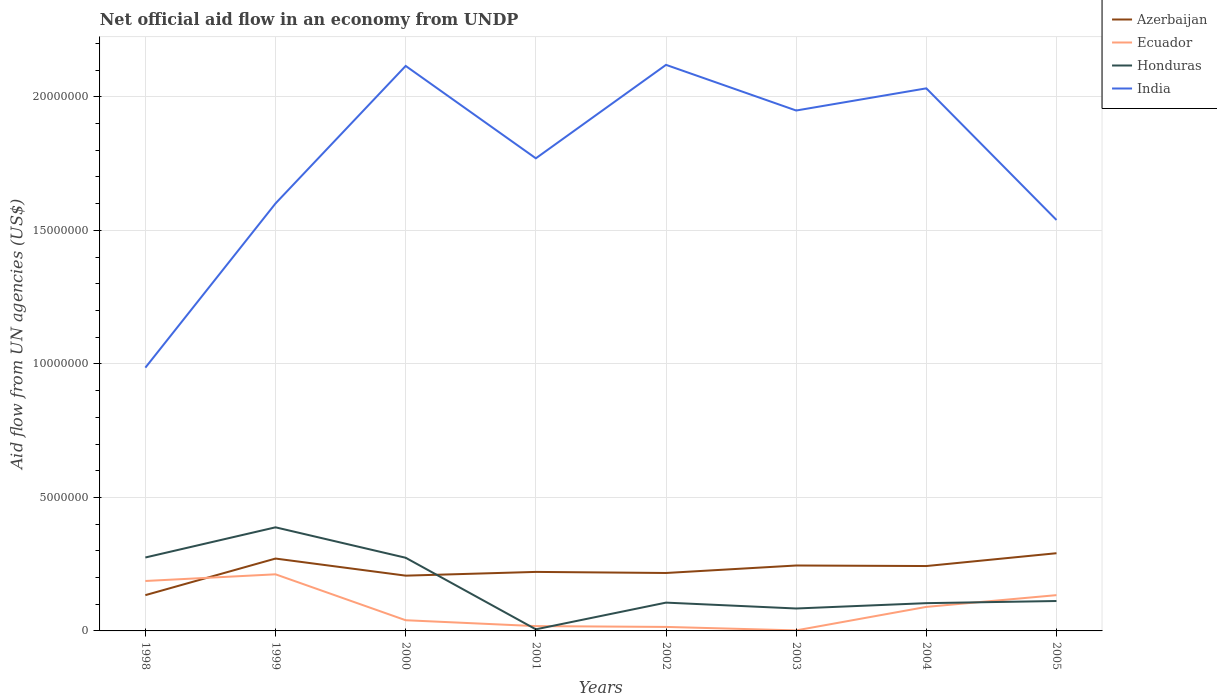Is the number of lines equal to the number of legend labels?
Offer a very short reply. Yes. Across all years, what is the maximum net official aid flow in Honduras?
Offer a very short reply. 6.00e+04. What is the total net official aid flow in India in the graph?
Offer a very short reply. 4.93e+06. What is the difference between the highest and the second highest net official aid flow in India?
Offer a terse response. 1.13e+07. Is the net official aid flow in India strictly greater than the net official aid flow in Ecuador over the years?
Your answer should be very brief. No. What is the difference between two consecutive major ticks on the Y-axis?
Your answer should be very brief. 5.00e+06. Are the values on the major ticks of Y-axis written in scientific E-notation?
Your answer should be very brief. No. Does the graph contain any zero values?
Your response must be concise. No. How many legend labels are there?
Your response must be concise. 4. What is the title of the graph?
Your answer should be compact. Net official aid flow in an economy from UNDP. What is the label or title of the Y-axis?
Provide a succinct answer. Aid flow from UN agencies (US$). What is the Aid flow from UN agencies (US$) of Azerbaijan in 1998?
Your answer should be very brief. 1.34e+06. What is the Aid flow from UN agencies (US$) of Ecuador in 1998?
Your answer should be compact. 1.87e+06. What is the Aid flow from UN agencies (US$) in Honduras in 1998?
Provide a short and direct response. 2.75e+06. What is the Aid flow from UN agencies (US$) of India in 1998?
Your answer should be very brief. 9.86e+06. What is the Aid flow from UN agencies (US$) of Azerbaijan in 1999?
Keep it short and to the point. 2.71e+06. What is the Aid flow from UN agencies (US$) of Ecuador in 1999?
Give a very brief answer. 2.12e+06. What is the Aid flow from UN agencies (US$) in Honduras in 1999?
Keep it short and to the point. 3.88e+06. What is the Aid flow from UN agencies (US$) in India in 1999?
Your answer should be compact. 1.60e+07. What is the Aid flow from UN agencies (US$) in Azerbaijan in 2000?
Give a very brief answer. 2.07e+06. What is the Aid flow from UN agencies (US$) of Ecuador in 2000?
Offer a very short reply. 4.00e+05. What is the Aid flow from UN agencies (US$) in Honduras in 2000?
Keep it short and to the point. 2.74e+06. What is the Aid flow from UN agencies (US$) in India in 2000?
Provide a succinct answer. 2.12e+07. What is the Aid flow from UN agencies (US$) in Azerbaijan in 2001?
Keep it short and to the point. 2.21e+06. What is the Aid flow from UN agencies (US$) in Ecuador in 2001?
Provide a succinct answer. 1.80e+05. What is the Aid flow from UN agencies (US$) of India in 2001?
Give a very brief answer. 1.77e+07. What is the Aid flow from UN agencies (US$) in Azerbaijan in 2002?
Your response must be concise. 2.17e+06. What is the Aid flow from UN agencies (US$) in Ecuador in 2002?
Your answer should be compact. 1.50e+05. What is the Aid flow from UN agencies (US$) of Honduras in 2002?
Your answer should be very brief. 1.06e+06. What is the Aid flow from UN agencies (US$) of India in 2002?
Your response must be concise. 2.12e+07. What is the Aid flow from UN agencies (US$) in Azerbaijan in 2003?
Offer a terse response. 2.45e+06. What is the Aid flow from UN agencies (US$) in Honduras in 2003?
Provide a succinct answer. 8.40e+05. What is the Aid flow from UN agencies (US$) in India in 2003?
Provide a short and direct response. 1.95e+07. What is the Aid flow from UN agencies (US$) in Azerbaijan in 2004?
Offer a very short reply. 2.43e+06. What is the Aid flow from UN agencies (US$) of Ecuador in 2004?
Keep it short and to the point. 9.00e+05. What is the Aid flow from UN agencies (US$) in Honduras in 2004?
Offer a very short reply. 1.04e+06. What is the Aid flow from UN agencies (US$) in India in 2004?
Provide a succinct answer. 2.03e+07. What is the Aid flow from UN agencies (US$) of Azerbaijan in 2005?
Offer a very short reply. 2.91e+06. What is the Aid flow from UN agencies (US$) in Ecuador in 2005?
Your response must be concise. 1.34e+06. What is the Aid flow from UN agencies (US$) in Honduras in 2005?
Keep it short and to the point. 1.12e+06. What is the Aid flow from UN agencies (US$) of India in 2005?
Provide a short and direct response. 1.54e+07. Across all years, what is the maximum Aid flow from UN agencies (US$) of Azerbaijan?
Ensure brevity in your answer.  2.91e+06. Across all years, what is the maximum Aid flow from UN agencies (US$) in Ecuador?
Make the answer very short. 2.12e+06. Across all years, what is the maximum Aid flow from UN agencies (US$) in Honduras?
Provide a succinct answer. 3.88e+06. Across all years, what is the maximum Aid flow from UN agencies (US$) of India?
Your response must be concise. 2.12e+07. Across all years, what is the minimum Aid flow from UN agencies (US$) of Azerbaijan?
Your answer should be very brief. 1.34e+06. Across all years, what is the minimum Aid flow from UN agencies (US$) of Honduras?
Make the answer very short. 6.00e+04. Across all years, what is the minimum Aid flow from UN agencies (US$) in India?
Your answer should be very brief. 9.86e+06. What is the total Aid flow from UN agencies (US$) of Azerbaijan in the graph?
Give a very brief answer. 1.83e+07. What is the total Aid flow from UN agencies (US$) of Ecuador in the graph?
Keep it short and to the point. 6.98e+06. What is the total Aid flow from UN agencies (US$) of Honduras in the graph?
Your answer should be compact. 1.35e+07. What is the total Aid flow from UN agencies (US$) in India in the graph?
Offer a very short reply. 1.41e+08. What is the difference between the Aid flow from UN agencies (US$) in Azerbaijan in 1998 and that in 1999?
Provide a succinct answer. -1.37e+06. What is the difference between the Aid flow from UN agencies (US$) in Honduras in 1998 and that in 1999?
Offer a terse response. -1.13e+06. What is the difference between the Aid flow from UN agencies (US$) in India in 1998 and that in 1999?
Give a very brief answer. -6.15e+06. What is the difference between the Aid flow from UN agencies (US$) in Azerbaijan in 1998 and that in 2000?
Give a very brief answer. -7.30e+05. What is the difference between the Aid flow from UN agencies (US$) of Ecuador in 1998 and that in 2000?
Make the answer very short. 1.47e+06. What is the difference between the Aid flow from UN agencies (US$) of Honduras in 1998 and that in 2000?
Offer a very short reply. 10000. What is the difference between the Aid flow from UN agencies (US$) of India in 1998 and that in 2000?
Your answer should be very brief. -1.13e+07. What is the difference between the Aid flow from UN agencies (US$) in Azerbaijan in 1998 and that in 2001?
Provide a succinct answer. -8.70e+05. What is the difference between the Aid flow from UN agencies (US$) in Ecuador in 1998 and that in 2001?
Offer a very short reply. 1.69e+06. What is the difference between the Aid flow from UN agencies (US$) of Honduras in 1998 and that in 2001?
Give a very brief answer. 2.69e+06. What is the difference between the Aid flow from UN agencies (US$) of India in 1998 and that in 2001?
Offer a very short reply. -7.84e+06. What is the difference between the Aid flow from UN agencies (US$) in Azerbaijan in 1998 and that in 2002?
Ensure brevity in your answer.  -8.30e+05. What is the difference between the Aid flow from UN agencies (US$) in Ecuador in 1998 and that in 2002?
Provide a short and direct response. 1.72e+06. What is the difference between the Aid flow from UN agencies (US$) in Honduras in 1998 and that in 2002?
Offer a terse response. 1.69e+06. What is the difference between the Aid flow from UN agencies (US$) in India in 1998 and that in 2002?
Offer a very short reply. -1.13e+07. What is the difference between the Aid flow from UN agencies (US$) of Azerbaijan in 1998 and that in 2003?
Offer a very short reply. -1.11e+06. What is the difference between the Aid flow from UN agencies (US$) of Ecuador in 1998 and that in 2003?
Make the answer very short. 1.85e+06. What is the difference between the Aid flow from UN agencies (US$) in Honduras in 1998 and that in 2003?
Your response must be concise. 1.91e+06. What is the difference between the Aid flow from UN agencies (US$) of India in 1998 and that in 2003?
Your response must be concise. -9.63e+06. What is the difference between the Aid flow from UN agencies (US$) in Azerbaijan in 1998 and that in 2004?
Provide a short and direct response. -1.09e+06. What is the difference between the Aid flow from UN agencies (US$) in Ecuador in 1998 and that in 2004?
Offer a very short reply. 9.70e+05. What is the difference between the Aid flow from UN agencies (US$) in Honduras in 1998 and that in 2004?
Offer a very short reply. 1.71e+06. What is the difference between the Aid flow from UN agencies (US$) of India in 1998 and that in 2004?
Give a very brief answer. -1.05e+07. What is the difference between the Aid flow from UN agencies (US$) in Azerbaijan in 1998 and that in 2005?
Give a very brief answer. -1.57e+06. What is the difference between the Aid flow from UN agencies (US$) in Ecuador in 1998 and that in 2005?
Ensure brevity in your answer.  5.30e+05. What is the difference between the Aid flow from UN agencies (US$) in Honduras in 1998 and that in 2005?
Give a very brief answer. 1.63e+06. What is the difference between the Aid flow from UN agencies (US$) in India in 1998 and that in 2005?
Provide a short and direct response. -5.53e+06. What is the difference between the Aid flow from UN agencies (US$) in Azerbaijan in 1999 and that in 2000?
Keep it short and to the point. 6.40e+05. What is the difference between the Aid flow from UN agencies (US$) in Ecuador in 1999 and that in 2000?
Give a very brief answer. 1.72e+06. What is the difference between the Aid flow from UN agencies (US$) of Honduras in 1999 and that in 2000?
Ensure brevity in your answer.  1.14e+06. What is the difference between the Aid flow from UN agencies (US$) of India in 1999 and that in 2000?
Offer a very short reply. -5.15e+06. What is the difference between the Aid flow from UN agencies (US$) of Ecuador in 1999 and that in 2001?
Offer a very short reply. 1.94e+06. What is the difference between the Aid flow from UN agencies (US$) of Honduras in 1999 and that in 2001?
Make the answer very short. 3.82e+06. What is the difference between the Aid flow from UN agencies (US$) of India in 1999 and that in 2001?
Provide a short and direct response. -1.69e+06. What is the difference between the Aid flow from UN agencies (US$) of Azerbaijan in 1999 and that in 2002?
Keep it short and to the point. 5.40e+05. What is the difference between the Aid flow from UN agencies (US$) in Ecuador in 1999 and that in 2002?
Your response must be concise. 1.97e+06. What is the difference between the Aid flow from UN agencies (US$) in Honduras in 1999 and that in 2002?
Offer a very short reply. 2.82e+06. What is the difference between the Aid flow from UN agencies (US$) of India in 1999 and that in 2002?
Give a very brief answer. -5.19e+06. What is the difference between the Aid flow from UN agencies (US$) in Azerbaijan in 1999 and that in 2003?
Offer a very short reply. 2.60e+05. What is the difference between the Aid flow from UN agencies (US$) in Ecuador in 1999 and that in 2003?
Your response must be concise. 2.10e+06. What is the difference between the Aid flow from UN agencies (US$) in Honduras in 1999 and that in 2003?
Provide a succinct answer. 3.04e+06. What is the difference between the Aid flow from UN agencies (US$) in India in 1999 and that in 2003?
Offer a very short reply. -3.48e+06. What is the difference between the Aid flow from UN agencies (US$) of Ecuador in 1999 and that in 2004?
Offer a very short reply. 1.22e+06. What is the difference between the Aid flow from UN agencies (US$) of Honduras in 1999 and that in 2004?
Offer a very short reply. 2.84e+06. What is the difference between the Aid flow from UN agencies (US$) in India in 1999 and that in 2004?
Your answer should be very brief. -4.31e+06. What is the difference between the Aid flow from UN agencies (US$) of Ecuador in 1999 and that in 2005?
Offer a very short reply. 7.80e+05. What is the difference between the Aid flow from UN agencies (US$) of Honduras in 1999 and that in 2005?
Give a very brief answer. 2.76e+06. What is the difference between the Aid flow from UN agencies (US$) in India in 1999 and that in 2005?
Offer a terse response. 6.20e+05. What is the difference between the Aid flow from UN agencies (US$) in Ecuador in 2000 and that in 2001?
Keep it short and to the point. 2.20e+05. What is the difference between the Aid flow from UN agencies (US$) of Honduras in 2000 and that in 2001?
Provide a short and direct response. 2.68e+06. What is the difference between the Aid flow from UN agencies (US$) of India in 2000 and that in 2001?
Your answer should be very brief. 3.46e+06. What is the difference between the Aid flow from UN agencies (US$) of Honduras in 2000 and that in 2002?
Your response must be concise. 1.68e+06. What is the difference between the Aid flow from UN agencies (US$) in India in 2000 and that in 2002?
Provide a succinct answer. -4.00e+04. What is the difference between the Aid flow from UN agencies (US$) of Azerbaijan in 2000 and that in 2003?
Offer a terse response. -3.80e+05. What is the difference between the Aid flow from UN agencies (US$) in Ecuador in 2000 and that in 2003?
Your response must be concise. 3.80e+05. What is the difference between the Aid flow from UN agencies (US$) of Honduras in 2000 and that in 2003?
Give a very brief answer. 1.90e+06. What is the difference between the Aid flow from UN agencies (US$) in India in 2000 and that in 2003?
Your answer should be very brief. 1.67e+06. What is the difference between the Aid flow from UN agencies (US$) in Azerbaijan in 2000 and that in 2004?
Provide a short and direct response. -3.60e+05. What is the difference between the Aid flow from UN agencies (US$) in Ecuador in 2000 and that in 2004?
Your answer should be compact. -5.00e+05. What is the difference between the Aid flow from UN agencies (US$) in Honduras in 2000 and that in 2004?
Your response must be concise. 1.70e+06. What is the difference between the Aid flow from UN agencies (US$) of India in 2000 and that in 2004?
Your answer should be compact. 8.40e+05. What is the difference between the Aid flow from UN agencies (US$) in Azerbaijan in 2000 and that in 2005?
Keep it short and to the point. -8.40e+05. What is the difference between the Aid flow from UN agencies (US$) of Ecuador in 2000 and that in 2005?
Make the answer very short. -9.40e+05. What is the difference between the Aid flow from UN agencies (US$) of Honduras in 2000 and that in 2005?
Ensure brevity in your answer.  1.62e+06. What is the difference between the Aid flow from UN agencies (US$) in India in 2000 and that in 2005?
Keep it short and to the point. 5.77e+06. What is the difference between the Aid flow from UN agencies (US$) of Azerbaijan in 2001 and that in 2002?
Make the answer very short. 4.00e+04. What is the difference between the Aid flow from UN agencies (US$) of Ecuador in 2001 and that in 2002?
Keep it short and to the point. 3.00e+04. What is the difference between the Aid flow from UN agencies (US$) in India in 2001 and that in 2002?
Offer a very short reply. -3.50e+06. What is the difference between the Aid flow from UN agencies (US$) in Azerbaijan in 2001 and that in 2003?
Your answer should be compact. -2.40e+05. What is the difference between the Aid flow from UN agencies (US$) of Honduras in 2001 and that in 2003?
Make the answer very short. -7.80e+05. What is the difference between the Aid flow from UN agencies (US$) of India in 2001 and that in 2003?
Your answer should be compact. -1.79e+06. What is the difference between the Aid flow from UN agencies (US$) in Azerbaijan in 2001 and that in 2004?
Your answer should be compact. -2.20e+05. What is the difference between the Aid flow from UN agencies (US$) of Ecuador in 2001 and that in 2004?
Provide a succinct answer. -7.20e+05. What is the difference between the Aid flow from UN agencies (US$) of Honduras in 2001 and that in 2004?
Keep it short and to the point. -9.80e+05. What is the difference between the Aid flow from UN agencies (US$) in India in 2001 and that in 2004?
Keep it short and to the point. -2.62e+06. What is the difference between the Aid flow from UN agencies (US$) in Azerbaijan in 2001 and that in 2005?
Your answer should be compact. -7.00e+05. What is the difference between the Aid flow from UN agencies (US$) of Ecuador in 2001 and that in 2005?
Offer a terse response. -1.16e+06. What is the difference between the Aid flow from UN agencies (US$) of Honduras in 2001 and that in 2005?
Your response must be concise. -1.06e+06. What is the difference between the Aid flow from UN agencies (US$) in India in 2001 and that in 2005?
Offer a terse response. 2.31e+06. What is the difference between the Aid flow from UN agencies (US$) of Azerbaijan in 2002 and that in 2003?
Give a very brief answer. -2.80e+05. What is the difference between the Aid flow from UN agencies (US$) in Honduras in 2002 and that in 2003?
Ensure brevity in your answer.  2.20e+05. What is the difference between the Aid flow from UN agencies (US$) in India in 2002 and that in 2003?
Ensure brevity in your answer.  1.71e+06. What is the difference between the Aid flow from UN agencies (US$) of Ecuador in 2002 and that in 2004?
Your response must be concise. -7.50e+05. What is the difference between the Aid flow from UN agencies (US$) of India in 2002 and that in 2004?
Your response must be concise. 8.80e+05. What is the difference between the Aid flow from UN agencies (US$) in Azerbaijan in 2002 and that in 2005?
Your answer should be very brief. -7.40e+05. What is the difference between the Aid flow from UN agencies (US$) of Ecuador in 2002 and that in 2005?
Give a very brief answer. -1.19e+06. What is the difference between the Aid flow from UN agencies (US$) in India in 2002 and that in 2005?
Your answer should be compact. 5.81e+06. What is the difference between the Aid flow from UN agencies (US$) in Azerbaijan in 2003 and that in 2004?
Provide a short and direct response. 2.00e+04. What is the difference between the Aid flow from UN agencies (US$) in Ecuador in 2003 and that in 2004?
Keep it short and to the point. -8.80e+05. What is the difference between the Aid flow from UN agencies (US$) in Honduras in 2003 and that in 2004?
Make the answer very short. -2.00e+05. What is the difference between the Aid flow from UN agencies (US$) of India in 2003 and that in 2004?
Keep it short and to the point. -8.30e+05. What is the difference between the Aid flow from UN agencies (US$) of Azerbaijan in 2003 and that in 2005?
Offer a terse response. -4.60e+05. What is the difference between the Aid flow from UN agencies (US$) in Ecuador in 2003 and that in 2005?
Your answer should be very brief. -1.32e+06. What is the difference between the Aid flow from UN agencies (US$) of Honduras in 2003 and that in 2005?
Offer a terse response. -2.80e+05. What is the difference between the Aid flow from UN agencies (US$) of India in 2003 and that in 2005?
Provide a short and direct response. 4.10e+06. What is the difference between the Aid flow from UN agencies (US$) in Azerbaijan in 2004 and that in 2005?
Provide a short and direct response. -4.80e+05. What is the difference between the Aid flow from UN agencies (US$) of Ecuador in 2004 and that in 2005?
Offer a very short reply. -4.40e+05. What is the difference between the Aid flow from UN agencies (US$) of Honduras in 2004 and that in 2005?
Offer a very short reply. -8.00e+04. What is the difference between the Aid flow from UN agencies (US$) in India in 2004 and that in 2005?
Make the answer very short. 4.93e+06. What is the difference between the Aid flow from UN agencies (US$) of Azerbaijan in 1998 and the Aid flow from UN agencies (US$) of Ecuador in 1999?
Make the answer very short. -7.80e+05. What is the difference between the Aid flow from UN agencies (US$) in Azerbaijan in 1998 and the Aid flow from UN agencies (US$) in Honduras in 1999?
Offer a very short reply. -2.54e+06. What is the difference between the Aid flow from UN agencies (US$) in Azerbaijan in 1998 and the Aid flow from UN agencies (US$) in India in 1999?
Offer a very short reply. -1.47e+07. What is the difference between the Aid flow from UN agencies (US$) in Ecuador in 1998 and the Aid flow from UN agencies (US$) in Honduras in 1999?
Make the answer very short. -2.01e+06. What is the difference between the Aid flow from UN agencies (US$) of Ecuador in 1998 and the Aid flow from UN agencies (US$) of India in 1999?
Provide a short and direct response. -1.41e+07. What is the difference between the Aid flow from UN agencies (US$) of Honduras in 1998 and the Aid flow from UN agencies (US$) of India in 1999?
Your answer should be compact. -1.33e+07. What is the difference between the Aid flow from UN agencies (US$) in Azerbaijan in 1998 and the Aid flow from UN agencies (US$) in Ecuador in 2000?
Give a very brief answer. 9.40e+05. What is the difference between the Aid flow from UN agencies (US$) of Azerbaijan in 1998 and the Aid flow from UN agencies (US$) of Honduras in 2000?
Your response must be concise. -1.40e+06. What is the difference between the Aid flow from UN agencies (US$) in Azerbaijan in 1998 and the Aid flow from UN agencies (US$) in India in 2000?
Keep it short and to the point. -1.98e+07. What is the difference between the Aid flow from UN agencies (US$) of Ecuador in 1998 and the Aid flow from UN agencies (US$) of Honduras in 2000?
Ensure brevity in your answer.  -8.70e+05. What is the difference between the Aid flow from UN agencies (US$) of Ecuador in 1998 and the Aid flow from UN agencies (US$) of India in 2000?
Ensure brevity in your answer.  -1.93e+07. What is the difference between the Aid flow from UN agencies (US$) of Honduras in 1998 and the Aid flow from UN agencies (US$) of India in 2000?
Your answer should be compact. -1.84e+07. What is the difference between the Aid flow from UN agencies (US$) in Azerbaijan in 1998 and the Aid flow from UN agencies (US$) in Ecuador in 2001?
Provide a succinct answer. 1.16e+06. What is the difference between the Aid flow from UN agencies (US$) of Azerbaijan in 1998 and the Aid flow from UN agencies (US$) of Honduras in 2001?
Make the answer very short. 1.28e+06. What is the difference between the Aid flow from UN agencies (US$) in Azerbaijan in 1998 and the Aid flow from UN agencies (US$) in India in 2001?
Offer a terse response. -1.64e+07. What is the difference between the Aid flow from UN agencies (US$) in Ecuador in 1998 and the Aid flow from UN agencies (US$) in Honduras in 2001?
Your response must be concise. 1.81e+06. What is the difference between the Aid flow from UN agencies (US$) of Ecuador in 1998 and the Aid flow from UN agencies (US$) of India in 2001?
Make the answer very short. -1.58e+07. What is the difference between the Aid flow from UN agencies (US$) of Honduras in 1998 and the Aid flow from UN agencies (US$) of India in 2001?
Offer a very short reply. -1.50e+07. What is the difference between the Aid flow from UN agencies (US$) of Azerbaijan in 1998 and the Aid flow from UN agencies (US$) of Ecuador in 2002?
Your answer should be very brief. 1.19e+06. What is the difference between the Aid flow from UN agencies (US$) in Azerbaijan in 1998 and the Aid flow from UN agencies (US$) in India in 2002?
Provide a short and direct response. -1.99e+07. What is the difference between the Aid flow from UN agencies (US$) in Ecuador in 1998 and the Aid flow from UN agencies (US$) in Honduras in 2002?
Provide a succinct answer. 8.10e+05. What is the difference between the Aid flow from UN agencies (US$) of Ecuador in 1998 and the Aid flow from UN agencies (US$) of India in 2002?
Provide a succinct answer. -1.93e+07. What is the difference between the Aid flow from UN agencies (US$) in Honduras in 1998 and the Aid flow from UN agencies (US$) in India in 2002?
Give a very brief answer. -1.84e+07. What is the difference between the Aid flow from UN agencies (US$) of Azerbaijan in 1998 and the Aid flow from UN agencies (US$) of Ecuador in 2003?
Provide a succinct answer. 1.32e+06. What is the difference between the Aid flow from UN agencies (US$) of Azerbaijan in 1998 and the Aid flow from UN agencies (US$) of Honduras in 2003?
Your answer should be very brief. 5.00e+05. What is the difference between the Aid flow from UN agencies (US$) of Azerbaijan in 1998 and the Aid flow from UN agencies (US$) of India in 2003?
Your answer should be very brief. -1.82e+07. What is the difference between the Aid flow from UN agencies (US$) of Ecuador in 1998 and the Aid flow from UN agencies (US$) of Honduras in 2003?
Keep it short and to the point. 1.03e+06. What is the difference between the Aid flow from UN agencies (US$) in Ecuador in 1998 and the Aid flow from UN agencies (US$) in India in 2003?
Your answer should be compact. -1.76e+07. What is the difference between the Aid flow from UN agencies (US$) of Honduras in 1998 and the Aid flow from UN agencies (US$) of India in 2003?
Your response must be concise. -1.67e+07. What is the difference between the Aid flow from UN agencies (US$) of Azerbaijan in 1998 and the Aid flow from UN agencies (US$) of India in 2004?
Provide a succinct answer. -1.90e+07. What is the difference between the Aid flow from UN agencies (US$) in Ecuador in 1998 and the Aid flow from UN agencies (US$) in Honduras in 2004?
Your answer should be compact. 8.30e+05. What is the difference between the Aid flow from UN agencies (US$) in Ecuador in 1998 and the Aid flow from UN agencies (US$) in India in 2004?
Provide a succinct answer. -1.84e+07. What is the difference between the Aid flow from UN agencies (US$) of Honduras in 1998 and the Aid flow from UN agencies (US$) of India in 2004?
Provide a short and direct response. -1.76e+07. What is the difference between the Aid flow from UN agencies (US$) in Azerbaijan in 1998 and the Aid flow from UN agencies (US$) in Honduras in 2005?
Make the answer very short. 2.20e+05. What is the difference between the Aid flow from UN agencies (US$) of Azerbaijan in 1998 and the Aid flow from UN agencies (US$) of India in 2005?
Ensure brevity in your answer.  -1.40e+07. What is the difference between the Aid flow from UN agencies (US$) in Ecuador in 1998 and the Aid flow from UN agencies (US$) in Honduras in 2005?
Keep it short and to the point. 7.50e+05. What is the difference between the Aid flow from UN agencies (US$) in Ecuador in 1998 and the Aid flow from UN agencies (US$) in India in 2005?
Provide a short and direct response. -1.35e+07. What is the difference between the Aid flow from UN agencies (US$) of Honduras in 1998 and the Aid flow from UN agencies (US$) of India in 2005?
Give a very brief answer. -1.26e+07. What is the difference between the Aid flow from UN agencies (US$) of Azerbaijan in 1999 and the Aid flow from UN agencies (US$) of Ecuador in 2000?
Make the answer very short. 2.31e+06. What is the difference between the Aid flow from UN agencies (US$) of Azerbaijan in 1999 and the Aid flow from UN agencies (US$) of Honduras in 2000?
Provide a succinct answer. -3.00e+04. What is the difference between the Aid flow from UN agencies (US$) of Azerbaijan in 1999 and the Aid flow from UN agencies (US$) of India in 2000?
Make the answer very short. -1.84e+07. What is the difference between the Aid flow from UN agencies (US$) of Ecuador in 1999 and the Aid flow from UN agencies (US$) of Honduras in 2000?
Ensure brevity in your answer.  -6.20e+05. What is the difference between the Aid flow from UN agencies (US$) in Ecuador in 1999 and the Aid flow from UN agencies (US$) in India in 2000?
Provide a short and direct response. -1.90e+07. What is the difference between the Aid flow from UN agencies (US$) of Honduras in 1999 and the Aid flow from UN agencies (US$) of India in 2000?
Your response must be concise. -1.73e+07. What is the difference between the Aid flow from UN agencies (US$) of Azerbaijan in 1999 and the Aid flow from UN agencies (US$) of Ecuador in 2001?
Your response must be concise. 2.53e+06. What is the difference between the Aid flow from UN agencies (US$) of Azerbaijan in 1999 and the Aid flow from UN agencies (US$) of Honduras in 2001?
Ensure brevity in your answer.  2.65e+06. What is the difference between the Aid flow from UN agencies (US$) of Azerbaijan in 1999 and the Aid flow from UN agencies (US$) of India in 2001?
Offer a terse response. -1.50e+07. What is the difference between the Aid flow from UN agencies (US$) of Ecuador in 1999 and the Aid flow from UN agencies (US$) of Honduras in 2001?
Keep it short and to the point. 2.06e+06. What is the difference between the Aid flow from UN agencies (US$) of Ecuador in 1999 and the Aid flow from UN agencies (US$) of India in 2001?
Provide a short and direct response. -1.56e+07. What is the difference between the Aid flow from UN agencies (US$) of Honduras in 1999 and the Aid flow from UN agencies (US$) of India in 2001?
Your answer should be very brief. -1.38e+07. What is the difference between the Aid flow from UN agencies (US$) in Azerbaijan in 1999 and the Aid flow from UN agencies (US$) in Ecuador in 2002?
Your answer should be compact. 2.56e+06. What is the difference between the Aid flow from UN agencies (US$) of Azerbaijan in 1999 and the Aid flow from UN agencies (US$) of Honduras in 2002?
Make the answer very short. 1.65e+06. What is the difference between the Aid flow from UN agencies (US$) in Azerbaijan in 1999 and the Aid flow from UN agencies (US$) in India in 2002?
Provide a succinct answer. -1.85e+07. What is the difference between the Aid flow from UN agencies (US$) of Ecuador in 1999 and the Aid flow from UN agencies (US$) of Honduras in 2002?
Offer a very short reply. 1.06e+06. What is the difference between the Aid flow from UN agencies (US$) in Ecuador in 1999 and the Aid flow from UN agencies (US$) in India in 2002?
Provide a succinct answer. -1.91e+07. What is the difference between the Aid flow from UN agencies (US$) of Honduras in 1999 and the Aid flow from UN agencies (US$) of India in 2002?
Offer a terse response. -1.73e+07. What is the difference between the Aid flow from UN agencies (US$) in Azerbaijan in 1999 and the Aid flow from UN agencies (US$) in Ecuador in 2003?
Offer a very short reply. 2.69e+06. What is the difference between the Aid flow from UN agencies (US$) of Azerbaijan in 1999 and the Aid flow from UN agencies (US$) of Honduras in 2003?
Provide a succinct answer. 1.87e+06. What is the difference between the Aid flow from UN agencies (US$) in Azerbaijan in 1999 and the Aid flow from UN agencies (US$) in India in 2003?
Your answer should be very brief. -1.68e+07. What is the difference between the Aid flow from UN agencies (US$) in Ecuador in 1999 and the Aid flow from UN agencies (US$) in Honduras in 2003?
Make the answer very short. 1.28e+06. What is the difference between the Aid flow from UN agencies (US$) of Ecuador in 1999 and the Aid flow from UN agencies (US$) of India in 2003?
Offer a very short reply. -1.74e+07. What is the difference between the Aid flow from UN agencies (US$) in Honduras in 1999 and the Aid flow from UN agencies (US$) in India in 2003?
Ensure brevity in your answer.  -1.56e+07. What is the difference between the Aid flow from UN agencies (US$) of Azerbaijan in 1999 and the Aid flow from UN agencies (US$) of Ecuador in 2004?
Your answer should be compact. 1.81e+06. What is the difference between the Aid flow from UN agencies (US$) of Azerbaijan in 1999 and the Aid flow from UN agencies (US$) of Honduras in 2004?
Your answer should be compact. 1.67e+06. What is the difference between the Aid flow from UN agencies (US$) in Azerbaijan in 1999 and the Aid flow from UN agencies (US$) in India in 2004?
Ensure brevity in your answer.  -1.76e+07. What is the difference between the Aid flow from UN agencies (US$) in Ecuador in 1999 and the Aid flow from UN agencies (US$) in Honduras in 2004?
Your response must be concise. 1.08e+06. What is the difference between the Aid flow from UN agencies (US$) of Ecuador in 1999 and the Aid flow from UN agencies (US$) of India in 2004?
Keep it short and to the point. -1.82e+07. What is the difference between the Aid flow from UN agencies (US$) of Honduras in 1999 and the Aid flow from UN agencies (US$) of India in 2004?
Ensure brevity in your answer.  -1.64e+07. What is the difference between the Aid flow from UN agencies (US$) in Azerbaijan in 1999 and the Aid flow from UN agencies (US$) in Ecuador in 2005?
Provide a succinct answer. 1.37e+06. What is the difference between the Aid flow from UN agencies (US$) of Azerbaijan in 1999 and the Aid flow from UN agencies (US$) of Honduras in 2005?
Give a very brief answer. 1.59e+06. What is the difference between the Aid flow from UN agencies (US$) of Azerbaijan in 1999 and the Aid flow from UN agencies (US$) of India in 2005?
Keep it short and to the point. -1.27e+07. What is the difference between the Aid flow from UN agencies (US$) in Ecuador in 1999 and the Aid flow from UN agencies (US$) in Honduras in 2005?
Keep it short and to the point. 1.00e+06. What is the difference between the Aid flow from UN agencies (US$) in Ecuador in 1999 and the Aid flow from UN agencies (US$) in India in 2005?
Give a very brief answer. -1.33e+07. What is the difference between the Aid flow from UN agencies (US$) of Honduras in 1999 and the Aid flow from UN agencies (US$) of India in 2005?
Make the answer very short. -1.15e+07. What is the difference between the Aid flow from UN agencies (US$) in Azerbaijan in 2000 and the Aid flow from UN agencies (US$) in Ecuador in 2001?
Provide a short and direct response. 1.89e+06. What is the difference between the Aid flow from UN agencies (US$) of Azerbaijan in 2000 and the Aid flow from UN agencies (US$) of Honduras in 2001?
Your answer should be compact. 2.01e+06. What is the difference between the Aid flow from UN agencies (US$) of Azerbaijan in 2000 and the Aid flow from UN agencies (US$) of India in 2001?
Offer a terse response. -1.56e+07. What is the difference between the Aid flow from UN agencies (US$) of Ecuador in 2000 and the Aid flow from UN agencies (US$) of India in 2001?
Offer a very short reply. -1.73e+07. What is the difference between the Aid flow from UN agencies (US$) of Honduras in 2000 and the Aid flow from UN agencies (US$) of India in 2001?
Make the answer very short. -1.50e+07. What is the difference between the Aid flow from UN agencies (US$) in Azerbaijan in 2000 and the Aid flow from UN agencies (US$) in Ecuador in 2002?
Your answer should be compact. 1.92e+06. What is the difference between the Aid flow from UN agencies (US$) in Azerbaijan in 2000 and the Aid flow from UN agencies (US$) in Honduras in 2002?
Make the answer very short. 1.01e+06. What is the difference between the Aid flow from UN agencies (US$) in Azerbaijan in 2000 and the Aid flow from UN agencies (US$) in India in 2002?
Make the answer very short. -1.91e+07. What is the difference between the Aid flow from UN agencies (US$) in Ecuador in 2000 and the Aid flow from UN agencies (US$) in Honduras in 2002?
Give a very brief answer. -6.60e+05. What is the difference between the Aid flow from UN agencies (US$) in Ecuador in 2000 and the Aid flow from UN agencies (US$) in India in 2002?
Give a very brief answer. -2.08e+07. What is the difference between the Aid flow from UN agencies (US$) of Honduras in 2000 and the Aid flow from UN agencies (US$) of India in 2002?
Offer a terse response. -1.85e+07. What is the difference between the Aid flow from UN agencies (US$) in Azerbaijan in 2000 and the Aid flow from UN agencies (US$) in Ecuador in 2003?
Provide a short and direct response. 2.05e+06. What is the difference between the Aid flow from UN agencies (US$) of Azerbaijan in 2000 and the Aid flow from UN agencies (US$) of Honduras in 2003?
Provide a short and direct response. 1.23e+06. What is the difference between the Aid flow from UN agencies (US$) of Azerbaijan in 2000 and the Aid flow from UN agencies (US$) of India in 2003?
Your response must be concise. -1.74e+07. What is the difference between the Aid flow from UN agencies (US$) in Ecuador in 2000 and the Aid flow from UN agencies (US$) in Honduras in 2003?
Give a very brief answer. -4.40e+05. What is the difference between the Aid flow from UN agencies (US$) in Ecuador in 2000 and the Aid flow from UN agencies (US$) in India in 2003?
Offer a very short reply. -1.91e+07. What is the difference between the Aid flow from UN agencies (US$) of Honduras in 2000 and the Aid flow from UN agencies (US$) of India in 2003?
Offer a terse response. -1.68e+07. What is the difference between the Aid flow from UN agencies (US$) in Azerbaijan in 2000 and the Aid flow from UN agencies (US$) in Ecuador in 2004?
Make the answer very short. 1.17e+06. What is the difference between the Aid flow from UN agencies (US$) of Azerbaijan in 2000 and the Aid flow from UN agencies (US$) of Honduras in 2004?
Your answer should be very brief. 1.03e+06. What is the difference between the Aid flow from UN agencies (US$) in Azerbaijan in 2000 and the Aid flow from UN agencies (US$) in India in 2004?
Ensure brevity in your answer.  -1.82e+07. What is the difference between the Aid flow from UN agencies (US$) of Ecuador in 2000 and the Aid flow from UN agencies (US$) of Honduras in 2004?
Provide a short and direct response. -6.40e+05. What is the difference between the Aid flow from UN agencies (US$) in Ecuador in 2000 and the Aid flow from UN agencies (US$) in India in 2004?
Your response must be concise. -1.99e+07. What is the difference between the Aid flow from UN agencies (US$) in Honduras in 2000 and the Aid flow from UN agencies (US$) in India in 2004?
Offer a terse response. -1.76e+07. What is the difference between the Aid flow from UN agencies (US$) in Azerbaijan in 2000 and the Aid flow from UN agencies (US$) in Ecuador in 2005?
Offer a terse response. 7.30e+05. What is the difference between the Aid flow from UN agencies (US$) of Azerbaijan in 2000 and the Aid flow from UN agencies (US$) of Honduras in 2005?
Make the answer very short. 9.50e+05. What is the difference between the Aid flow from UN agencies (US$) of Azerbaijan in 2000 and the Aid flow from UN agencies (US$) of India in 2005?
Provide a short and direct response. -1.33e+07. What is the difference between the Aid flow from UN agencies (US$) in Ecuador in 2000 and the Aid flow from UN agencies (US$) in Honduras in 2005?
Keep it short and to the point. -7.20e+05. What is the difference between the Aid flow from UN agencies (US$) of Ecuador in 2000 and the Aid flow from UN agencies (US$) of India in 2005?
Make the answer very short. -1.50e+07. What is the difference between the Aid flow from UN agencies (US$) of Honduras in 2000 and the Aid flow from UN agencies (US$) of India in 2005?
Provide a succinct answer. -1.26e+07. What is the difference between the Aid flow from UN agencies (US$) in Azerbaijan in 2001 and the Aid flow from UN agencies (US$) in Ecuador in 2002?
Provide a succinct answer. 2.06e+06. What is the difference between the Aid flow from UN agencies (US$) of Azerbaijan in 2001 and the Aid flow from UN agencies (US$) of Honduras in 2002?
Make the answer very short. 1.15e+06. What is the difference between the Aid flow from UN agencies (US$) in Azerbaijan in 2001 and the Aid flow from UN agencies (US$) in India in 2002?
Ensure brevity in your answer.  -1.90e+07. What is the difference between the Aid flow from UN agencies (US$) in Ecuador in 2001 and the Aid flow from UN agencies (US$) in Honduras in 2002?
Provide a succinct answer. -8.80e+05. What is the difference between the Aid flow from UN agencies (US$) of Ecuador in 2001 and the Aid flow from UN agencies (US$) of India in 2002?
Provide a short and direct response. -2.10e+07. What is the difference between the Aid flow from UN agencies (US$) of Honduras in 2001 and the Aid flow from UN agencies (US$) of India in 2002?
Your response must be concise. -2.11e+07. What is the difference between the Aid flow from UN agencies (US$) of Azerbaijan in 2001 and the Aid flow from UN agencies (US$) of Ecuador in 2003?
Provide a short and direct response. 2.19e+06. What is the difference between the Aid flow from UN agencies (US$) in Azerbaijan in 2001 and the Aid flow from UN agencies (US$) in Honduras in 2003?
Ensure brevity in your answer.  1.37e+06. What is the difference between the Aid flow from UN agencies (US$) of Azerbaijan in 2001 and the Aid flow from UN agencies (US$) of India in 2003?
Your response must be concise. -1.73e+07. What is the difference between the Aid flow from UN agencies (US$) in Ecuador in 2001 and the Aid flow from UN agencies (US$) in Honduras in 2003?
Ensure brevity in your answer.  -6.60e+05. What is the difference between the Aid flow from UN agencies (US$) in Ecuador in 2001 and the Aid flow from UN agencies (US$) in India in 2003?
Give a very brief answer. -1.93e+07. What is the difference between the Aid flow from UN agencies (US$) of Honduras in 2001 and the Aid flow from UN agencies (US$) of India in 2003?
Your response must be concise. -1.94e+07. What is the difference between the Aid flow from UN agencies (US$) in Azerbaijan in 2001 and the Aid flow from UN agencies (US$) in Ecuador in 2004?
Ensure brevity in your answer.  1.31e+06. What is the difference between the Aid flow from UN agencies (US$) in Azerbaijan in 2001 and the Aid flow from UN agencies (US$) in Honduras in 2004?
Offer a very short reply. 1.17e+06. What is the difference between the Aid flow from UN agencies (US$) of Azerbaijan in 2001 and the Aid flow from UN agencies (US$) of India in 2004?
Your answer should be compact. -1.81e+07. What is the difference between the Aid flow from UN agencies (US$) of Ecuador in 2001 and the Aid flow from UN agencies (US$) of Honduras in 2004?
Provide a succinct answer. -8.60e+05. What is the difference between the Aid flow from UN agencies (US$) of Ecuador in 2001 and the Aid flow from UN agencies (US$) of India in 2004?
Your response must be concise. -2.01e+07. What is the difference between the Aid flow from UN agencies (US$) of Honduras in 2001 and the Aid flow from UN agencies (US$) of India in 2004?
Give a very brief answer. -2.03e+07. What is the difference between the Aid flow from UN agencies (US$) of Azerbaijan in 2001 and the Aid flow from UN agencies (US$) of Ecuador in 2005?
Offer a very short reply. 8.70e+05. What is the difference between the Aid flow from UN agencies (US$) of Azerbaijan in 2001 and the Aid flow from UN agencies (US$) of Honduras in 2005?
Ensure brevity in your answer.  1.09e+06. What is the difference between the Aid flow from UN agencies (US$) of Azerbaijan in 2001 and the Aid flow from UN agencies (US$) of India in 2005?
Offer a terse response. -1.32e+07. What is the difference between the Aid flow from UN agencies (US$) in Ecuador in 2001 and the Aid flow from UN agencies (US$) in Honduras in 2005?
Give a very brief answer. -9.40e+05. What is the difference between the Aid flow from UN agencies (US$) of Ecuador in 2001 and the Aid flow from UN agencies (US$) of India in 2005?
Make the answer very short. -1.52e+07. What is the difference between the Aid flow from UN agencies (US$) in Honduras in 2001 and the Aid flow from UN agencies (US$) in India in 2005?
Offer a terse response. -1.53e+07. What is the difference between the Aid flow from UN agencies (US$) of Azerbaijan in 2002 and the Aid flow from UN agencies (US$) of Ecuador in 2003?
Offer a terse response. 2.15e+06. What is the difference between the Aid flow from UN agencies (US$) in Azerbaijan in 2002 and the Aid flow from UN agencies (US$) in Honduras in 2003?
Provide a succinct answer. 1.33e+06. What is the difference between the Aid flow from UN agencies (US$) of Azerbaijan in 2002 and the Aid flow from UN agencies (US$) of India in 2003?
Offer a terse response. -1.73e+07. What is the difference between the Aid flow from UN agencies (US$) of Ecuador in 2002 and the Aid flow from UN agencies (US$) of Honduras in 2003?
Offer a very short reply. -6.90e+05. What is the difference between the Aid flow from UN agencies (US$) in Ecuador in 2002 and the Aid flow from UN agencies (US$) in India in 2003?
Offer a very short reply. -1.93e+07. What is the difference between the Aid flow from UN agencies (US$) in Honduras in 2002 and the Aid flow from UN agencies (US$) in India in 2003?
Make the answer very short. -1.84e+07. What is the difference between the Aid flow from UN agencies (US$) of Azerbaijan in 2002 and the Aid flow from UN agencies (US$) of Ecuador in 2004?
Offer a terse response. 1.27e+06. What is the difference between the Aid flow from UN agencies (US$) in Azerbaijan in 2002 and the Aid flow from UN agencies (US$) in Honduras in 2004?
Your response must be concise. 1.13e+06. What is the difference between the Aid flow from UN agencies (US$) of Azerbaijan in 2002 and the Aid flow from UN agencies (US$) of India in 2004?
Give a very brief answer. -1.82e+07. What is the difference between the Aid flow from UN agencies (US$) of Ecuador in 2002 and the Aid flow from UN agencies (US$) of Honduras in 2004?
Your response must be concise. -8.90e+05. What is the difference between the Aid flow from UN agencies (US$) in Ecuador in 2002 and the Aid flow from UN agencies (US$) in India in 2004?
Keep it short and to the point. -2.02e+07. What is the difference between the Aid flow from UN agencies (US$) in Honduras in 2002 and the Aid flow from UN agencies (US$) in India in 2004?
Your answer should be very brief. -1.93e+07. What is the difference between the Aid flow from UN agencies (US$) in Azerbaijan in 2002 and the Aid flow from UN agencies (US$) in Ecuador in 2005?
Make the answer very short. 8.30e+05. What is the difference between the Aid flow from UN agencies (US$) in Azerbaijan in 2002 and the Aid flow from UN agencies (US$) in Honduras in 2005?
Your response must be concise. 1.05e+06. What is the difference between the Aid flow from UN agencies (US$) of Azerbaijan in 2002 and the Aid flow from UN agencies (US$) of India in 2005?
Your answer should be compact. -1.32e+07. What is the difference between the Aid flow from UN agencies (US$) in Ecuador in 2002 and the Aid flow from UN agencies (US$) in Honduras in 2005?
Your response must be concise. -9.70e+05. What is the difference between the Aid flow from UN agencies (US$) of Ecuador in 2002 and the Aid flow from UN agencies (US$) of India in 2005?
Your answer should be compact. -1.52e+07. What is the difference between the Aid flow from UN agencies (US$) in Honduras in 2002 and the Aid flow from UN agencies (US$) in India in 2005?
Make the answer very short. -1.43e+07. What is the difference between the Aid flow from UN agencies (US$) in Azerbaijan in 2003 and the Aid flow from UN agencies (US$) in Ecuador in 2004?
Offer a very short reply. 1.55e+06. What is the difference between the Aid flow from UN agencies (US$) of Azerbaijan in 2003 and the Aid flow from UN agencies (US$) of Honduras in 2004?
Provide a succinct answer. 1.41e+06. What is the difference between the Aid flow from UN agencies (US$) of Azerbaijan in 2003 and the Aid flow from UN agencies (US$) of India in 2004?
Offer a very short reply. -1.79e+07. What is the difference between the Aid flow from UN agencies (US$) of Ecuador in 2003 and the Aid flow from UN agencies (US$) of Honduras in 2004?
Provide a short and direct response. -1.02e+06. What is the difference between the Aid flow from UN agencies (US$) in Ecuador in 2003 and the Aid flow from UN agencies (US$) in India in 2004?
Offer a terse response. -2.03e+07. What is the difference between the Aid flow from UN agencies (US$) in Honduras in 2003 and the Aid flow from UN agencies (US$) in India in 2004?
Make the answer very short. -1.95e+07. What is the difference between the Aid flow from UN agencies (US$) in Azerbaijan in 2003 and the Aid flow from UN agencies (US$) in Ecuador in 2005?
Keep it short and to the point. 1.11e+06. What is the difference between the Aid flow from UN agencies (US$) of Azerbaijan in 2003 and the Aid flow from UN agencies (US$) of Honduras in 2005?
Keep it short and to the point. 1.33e+06. What is the difference between the Aid flow from UN agencies (US$) in Azerbaijan in 2003 and the Aid flow from UN agencies (US$) in India in 2005?
Your answer should be very brief. -1.29e+07. What is the difference between the Aid flow from UN agencies (US$) of Ecuador in 2003 and the Aid flow from UN agencies (US$) of Honduras in 2005?
Your response must be concise. -1.10e+06. What is the difference between the Aid flow from UN agencies (US$) in Ecuador in 2003 and the Aid flow from UN agencies (US$) in India in 2005?
Keep it short and to the point. -1.54e+07. What is the difference between the Aid flow from UN agencies (US$) in Honduras in 2003 and the Aid flow from UN agencies (US$) in India in 2005?
Your answer should be compact. -1.46e+07. What is the difference between the Aid flow from UN agencies (US$) in Azerbaijan in 2004 and the Aid flow from UN agencies (US$) in Ecuador in 2005?
Your answer should be very brief. 1.09e+06. What is the difference between the Aid flow from UN agencies (US$) in Azerbaijan in 2004 and the Aid flow from UN agencies (US$) in Honduras in 2005?
Your response must be concise. 1.31e+06. What is the difference between the Aid flow from UN agencies (US$) in Azerbaijan in 2004 and the Aid flow from UN agencies (US$) in India in 2005?
Offer a very short reply. -1.30e+07. What is the difference between the Aid flow from UN agencies (US$) of Ecuador in 2004 and the Aid flow from UN agencies (US$) of India in 2005?
Give a very brief answer. -1.45e+07. What is the difference between the Aid flow from UN agencies (US$) in Honduras in 2004 and the Aid flow from UN agencies (US$) in India in 2005?
Your answer should be compact. -1.44e+07. What is the average Aid flow from UN agencies (US$) of Azerbaijan per year?
Ensure brevity in your answer.  2.29e+06. What is the average Aid flow from UN agencies (US$) in Ecuador per year?
Offer a terse response. 8.72e+05. What is the average Aid flow from UN agencies (US$) in Honduras per year?
Offer a very short reply. 1.69e+06. What is the average Aid flow from UN agencies (US$) of India per year?
Your response must be concise. 1.76e+07. In the year 1998, what is the difference between the Aid flow from UN agencies (US$) of Azerbaijan and Aid flow from UN agencies (US$) of Ecuador?
Your answer should be very brief. -5.30e+05. In the year 1998, what is the difference between the Aid flow from UN agencies (US$) in Azerbaijan and Aid flow from UN agencies (US$) in Honduras?
Keep it short and to the point. -1.41e+06. In the year 1998, what is the difference between the Aid flow from UN agencies (US$) of Azerbaijan and Aid flow from UN agencies (US$) of India?
Offer a very short reply. -8.52e+06. In the year 1998, what is the difference between the Aid flow from UN agencies (US$) of Ecuador and Aid flow from UN agencies (US$) of Honduras?
Provide a short and direct response. -8.80e+05. In the year 1998, what is the difference between the Aid flow from UN agencies (US$) in Ecuador and Aid flow from UN agencies (US$) in India?
Your response must be concise. -7.99e+06. In the year 1998, what is the difference between the Aid flow from UN agencies (US$) of Honduras and Aid flow from UN agencies (US$) of India?
Your response must be concise. -7.11e+06. In the year 1999, what is the difference between the Aid flow from UN agencies (US$) of Azerbaijan and Aid flow from UN agencies (US$) of Ecuador?
Offer a very short reply. 5.90e+05. In the year 1999, what is the difference between the Aid flow from UN agencies (US$) of Azerbaijan and Aid flow from UN agencies (US$) of Honduras?
Your answer should be very brief. -1.17e+06. In the year 1999, what is the difference between the Aid flow from UN agencies (US$) of Azerbaijan and Aid flow from UN agencies (US$) of India?
Make the answer very short. -1.33e+07. In the year 1999, what is the difference between the Aid flow from UN agencies (US$) in Ecuador and Aid flow from UN agencies (US$) in Honduras?
Provide a succinct answer. -1.76e+06. In the year 1999, what is the difference between the Aid flow from UN agencies (US$) of Ecuador and Aid flow from UN agencies (US$) of India?
Ensure brevity in your answer.  -1.39e+07. In the year 1999, what is the difference between the Aid flow from UN agencies (US$) of Honduras and Aid flow from UN agencies (US$) of India?
Ensure brevity in your answer.  -1.21e+07. In the year 2000, what is the difference between the Aid flow from UN agencies (US$) of Azerbaijan and Aid flow from UN agencies (US$) of Ecuador?
Your answer should be very brief. 1.67e+06. In the year 2000, what is the difference between the Aid flow from UN agencies (US$) in Azerbaijan and Aid flow from UN agencies (US$) in Honduras?
Keep it short and to the point. -6.70e+05. In the year 2000, what is the difference between the Aid flow from UN agencies (US$) of Azerbaijan and Aid flow from UN agencies (US$) of India?
Offer a terse response. -1.91e+07. In the year 2000, what is the difference between the Aid flow from UN agencies (US$) in Ecuador and Aid flow from UN agencies (US$) in Honduras?
Your answer should be very brief. -2.34e+06. In the year 2000, what is the difference between the Aid flow from UN agencies (US$) in Ecuador and Aid flow from UN agencies (US$) in India?
Provide a succinct answer. -2.08e+07. In the year 2000, what is the difference between the Aid flow from UN agencies (US$) of Honduras and Aid flow from UN agencies (US$) of India?
Make the answer very short. -1.84e+07. In the year 2001, what is the difference between the Aid flow from UN agencies (US$) of Azerbaijan and Aid flow from UN agencies (US$) of Ecuador?
Give a very brief answer. 2.03e+06. In the year 2001, what is the difference between the Aid flow from UN agencies (US$) in Azerbaijan and Aid flow from UN agencies (US$) in Honduras?
Make the answer very short. 2.15e+06. In the year 2001, what is the difference between the Aid flow from UN agencies (US$) in Azerbaijan and Aid flow from UN agencies (US$) in India?
Provide a succinct answer. -1.55e+07. In the year 2001, what is the difference between the Aid flow from UN agencies (US$) of Ecuador and Aid flow from UN agencies (US$) of Honduras?
Offer a very short reply. 1.20e+05. In the year 2001, what is the difference between the Aid flow from UN agencies (US$) in Ecuador and Aid flow from UN agencies (US$) in India?
Provide a short and direct response. -1.75e+07. In the year 2001, what is the difference between the Aid flow from UN agencies (US$) in Honduras and Aid flow from UN agencies (US$) in India?
Give a very brief answer. -1.76e+07. In the year 2002, what is the difference between the Aid flow from UN agencies (US$) in Azerbaijan and Aid flow from UN agencies (US$) in Ecuador?
Offer a very short reply. 2.02e+06. In the year 2002, what is the difference between the Aid flow from UN agencies (US$) of Azerbaijan and Aid flow from UN agencies (US$) of Honduras?
Ensure brevity in your answer.  1.11e+06. In the year 2002, what is the difference between the Aid flow from UN agencies (US$) of Azerbaijan and Aid flow from UN agencies (US$) of India?
Offer a very short reply. -1.90e+07. In the year 2002, what is the difference between the Aid flow from UN agencies (US$) of Ecuador and Aid flow from UN agencies (US$) of Honduras?
Your response must be concise. -9.10e+05. In the year 2002, what is the difference between the Aid flow from UN agencies (US$) of Ecuador and Aid flow from UN agencies (US$) of India?
Your response must be concise. -2.10e+07. In the year 2002, what is the difference between the Aid flow from UN agencies (US$) of Honduras and Aid flow from UN agencies (US$) of India?
Offer a very short reply. -2.01e+07. In the year 2003, what is the difference between the Aid flow from UN agencies (US$) of Azerbaijan and Aid flow from UN agencies (US$) of Ecuador?
Ensure brevity in your answer.  2.43e+06. In the year 2003, what is the difference between the Aid flow from UN agencies (US$) of Azerbaijan and Aid flow from UN agencies (US$) of Honduras?
Offer a terse response. 1.61e+06. In the year 2003, what is the difference between the Aid flow from UN agencies (US$) of Azerbaijan and Aid flow from UN agencies (US$) of India?
Your answer should be compact. -1.70e+07. In the year 2003, what is the difference between the Aid flow from UN agencies (US$) of Ecuador and Aid flow from UN agencies (US$) of Honduras?
Offer a very short reply. -8.20e+05. In the year 2003, what is the difference between the Aid flow from UN agencies (US$) of Ecuador and Aid flow from UN agencies (US$) of India?
Ensure brevity in your answer.  -1.95e+07. In the year 2003, what is the difference between the Aid flow from UN agencies (US$) of Honduras and Aid flow from UN agencies (US$) of India?
Provide a short and direct response. -1.86e+07. In the year 2004, what is the difference between the Aid flow from UN agencies (US$) of Azerbaijan and Aid flow from UN agencies (US$) of Ecuador?
Provide a short and direct response. 1.53e+06. In the year 2004, what is the difference between the Aid flow from UN agencies (US$) of Azerbaijan and Aid flow from UN agencies (US$) of Honduras?
Offer a terse response. 1.39e+06. In the year 2004, what is the difference between the Aid flow from UN agencies (US$) in Azerbaijan and Aid flow from UN agencies (US$) in India?
Ensure brevity in your answer.  -1.79e+07. In the year 2004, what is the difference between the Aid flow from UN agencies (US$) of Ecuador and Aid flow from UN agencies (US$) of India?
Your answer should be very brief. -1.94e+07. In the year 2004, what is the difference between the Aid flow from UN agencies (US$) of Honduras and Aid flow from UN agencies (US$) of India?
Keep it short and to the point. -1.93e+07. In the year 2005, what is the difference between the Aid flow from UN agencies (US$) of Azerbaijan and Aid flow from UN agencies (US$) of Ecuador?
Offer a very short reply. 1.57e+06. In the year 2005, what is the difference between the Aid flow from UN agencies (US$) in Azerbaijan and Aid flow from UN agencies (US$) in Honduras?
Ensure brevity in your answer.  1.79e+06. In the year 2005, what is the difference between the Aid flow from UN agencies (US$) in Azerbaijan and Aid flow from UN agencies (US$) in India?
Provide a short and direct response. -1.25e+07. In the year 2005, what is the difference between the Aid flow from UN agencies (US$) of Ecuador and Aid flow from UN agencies (US$) of Honduras?
Your answer should be compact. 2.20e+05. In the year 2005, what is the difference between the Aid flow from UN agencies (US$) of Ecuador and Aid flow from UN agencies (US$) of India?
Keep it short and to the point. -1.40e+07. In the year 2005, what is the difference between the Aid flow from UN agencies (US$) in Honduras and Aid flow from UN agencies (US$) in India?
Keep it short and to the point. -1.43e+07. What is the ratio of the Aid flow from UN agencies (US$) of Azerbaijan in 1998 to that in 1999?
Offer a very short reply. 0.49. What is the ratio of the Aid flow from UN agencies (US$) of Ecuador in 1998 to that in 1999?
Your answer should be compact. 0.88. What is the ratio of the Aid flow from UN agencies (US$) in Honduras in 1998 to that in 1999?
Your response must be concise. 0.71. What is the ratio of the Aid flow from UN agencies (US$) of India in 1998 to that in 1999?
Offer a very short reply. 0.62. What is the ratio of the Aid flow from UN agencies (US$) in Azerbaijan in 1998 to that in 2000?
Provide a short and direct response. 0.65. What is the ratio of the Aid flow from UN agencies (US$) of Ecuador in 1998 to that in 2000?
Offer a terse response. 4.67. What is the ratio of the Aid flow from UN agencies (US$) in India in 1998 to that in 2000?
Offer a very short reply. 0.47. What is the ratio of the Aid flow from UN agencies (US$) of Azerbaijan in 1998 to that in 2001?
Your response must be concise. 0.61. What is the ratio of the Aid flow from UN agencies (US$) in Ecuador in 1998 to that in 2001?
Your answer should be very brief. 10.39. What is the ratio of the Aid flow from UN agencies (US$) in Honduras in 1998 to that in 2001?
Ensure brevity in your answer.  45.83. What is the ratio of the Aid flow from UN agencies (US$) in India in 1998 to that in 2001?
Offer a terse response. 0.56. What is the ratio of the Aid flow from UN agencies (US$) of Azerbaijan in 1998 to that in 2002?
Give a very brief answer. 0.62. What is the ratio of the Aid flow from UN agencies (US$) in Ecuador in 1998 to that in 2002?
Ensure brevity in your answer.  12.47. What is the ratio of the Aid flow from UN agencies (US$) of Honduras in 1998 to that in 2002?
Make the answer very short. 2.59. What is the ratio of the Aid flow from UN agencies (US$) in India in 1998 to that in 2002?
Your answer should be compact. 0.47. What is the ratio of the Aid flow from UN agencies (US$) in Azerbaijan in 1998 to that in 2003?
Your answer should be very brief. 0.55. What is the ratio of the Aid flow from UN agencies (US$) of Ecuador in 1998 to that in 2003?
Make the answer very short. 93.5. What is the ratio of the Aid flow from UN agencies (US$) of Honduras in 1998 to that in 2003?
Your response must be concise. 3.27. What is the ratio of the Aid flow from UN agencies (US$) of India in 1998 to that in 2003?
Ensure brevity in your answer.  0.51. What is the ratio of the Aid flow from UN agencies (US$) in Azerbaijan in 1998 to that in 2004?
Keep it short and to the point. 0.55. What is the ratio of the Aid flow from UN agencies (US$) in Ecuador in 1998 to that in 2004?
Offer a very short reply. 2.08. What is the ratio of the Aid flow from UN agencies (US$) of Honduras in 1998 to that in 2004?
Provide a short and direct response. 2.64. What is the ratio of the Aid flow from UN agencies (US$) in India in 1998 to that in 2004?
Offer a very short reply. 0.49. What is the ratio of the Aid flow from UN agencies (US$) in Azerbaijan in 1998 to that in 2005?
Your response must be concise. 0.46. What is the ratio of the Aid flow from UN agencies (US$) in Ecuador in 1998 to that in 2005?
Your response must be concise. 1.4. What is the ratio of the Aid flow from UN agencies (US$) of Honduras in 1998 to that in 2005?
Offer a very short reply. 2.46. What is the ratio of the Aid flow from UN agencies (US$) of India in 1998 to that in 2005?
Your answer should be very brief. 0.64. What is the ratio of the Aid flow from UN agencies (US$) in Azerbaijan in 1999 to that in 2000?
Your answer should be very brief. 1.31. What is the ratio of the Aid flow from UN agencies (US$) of Honduras in 1999 to that in 2000?
Your response must be concise. 1.42. What is the ratio of the Aid flow from UN agencies (US$) in India in 1999 to that in 2000?
Make the answer very short. 0.76. What is the ratio of the Aid flow from UN agencies (US$) in Azerbaijan in 1999 to that in 2001?
Offer a very short reply. 1.23. What is the ratio of the Aid flow from UN agencies (US$) of Ecuador in 1999 to that in 2001?
Keep it short and to the point. 11.78. What is the ratio of the Aid flow from UN agencies (US$) in Honduras in 1999 to that in 2001?
Your response must be concise. 64.67. What is the ratio of the Aid flow from UN agencies (US$) in India in 1999 to that in 2001?
Offer a very short reply. 0.9. What is the ratio of the Aid flow from UN agencies (US$) in Azerbaijan in 1999 to that in 2002?
Provide a succinct answer. 1.25. What is the ratio of the Aid flow from UN agencies (US$) in Ecuador in 1999 to that in 2002?
Offer a terse response. 14.13. What is the ratio of the Aid flow from UN agencies (US$) in Honduras in 1999 to that in 2002?
Make the answer very short. 3.66. What is the ratio of the Aid flow from UN agencies (US$) in India in 1999 to that in 2002?
Ensure brevity in your answer.  0.76. What is the ratio of the Aid flow from UN agencies (US$) of Azerbaijan in 1999 to that in 2003?
Your answer should be compact. 1.11. What is the ratio of the Aid flow from UN agencies (US$) of Ecuador in 1999 to that in 2003?
Make the answer very short. 106. What is the ratio of the Aid flow from UN agencies (US$) of Honduras in 1999 to that in 2003?
Your response must be concise. 4.62. What is the ratio of the Aid flow from UN agencies (US$) of India in 1999 to that in 2003?
Offer a terse response. 0.82. What is the ratio of the Aid flow from UN agencies (US$) of Azerbaijan in 1999 to that in 2004?
Your answer should be compact. 1.12. What is the ratio of the Aid flow from UN agencies (US$) of Ecuador in 1999 to that in 2004?
Ensure brevity in your answer.  2.36. What is the ratio of the Aid flow from UN agencies (US$) in Honduras in 1999 to that in 2004?
Make the answer very short. 3.73. What is the ratio of the Aid flow from UN agencies (US$) of India in 1999 to that in 2004?
Your answer should be very brief. 0.79. What is the ratio of the Aid flow from UN agencies (US$) in Azerbaijan in 1999 to that in 2005?
Offer a terse response. 0.93. What is the ratio of the Aid flow from UN agencies (US$) of Ecuador in 1999 to that in 2005?
Provide a succinct answer. 1.58. What is the ratio of the Aid flow from UN agencies (US$) in Honduras in 1999 to that in 2005?
Your answer should be compact. 3.46. What is the ratio of the Aid flow from UN agencies (US$) in India in 1999 to that in 2005?
Offer a terse response. 1.04. What is the ratio of the Aid flow from UN agencies (US$) in Azerbaijan in 2000 to that in 2001?
Your response must be concise. 0.94. What is the ratio of the Aid flow from UN agencies (US$) of Ecuador in 2000 to that in 2001?
Offer a very short reply. 2.22. What is the ratio of the Aid flow from UN agencies (US$) of Honduras in 2000 to that in 2001?
Give a very brief answer. 45.67. What is the ratio of the Aid flow from UN agencies (US$) in India in 2000 to that in 2001?
Your response must be concise. 1.2. What is the ratio of the Aid flow from UN agencies (US$) in Azerbaijan in 2000 to that in 2002?
Make the answer very short. 0.95. What is the ratio of the Aid flow from UN agencies (US$) in Ecuador in 2000 to that in 2002?
Provide a succinct answer. 2.67. What is the ratio of the Aid flow from UN agencies (US$) of Honduras in 2000 to that in 2002?
Keep it short and to the point. 2.58. What is the ratio of the Aid flow from UN agencies (US$) in Azerbaijan in 2000 to that in 2003?
Offer a terse response. 0.84. What is the ratio of the Aid flow from UN agencies (US$) in Honduras in 2000 to that in 2003?
Provide a short and direct response. 3.26. What is the ratio of the Aid flow from UN agencies (US$) of India in 2000 to that in 2003?
Provide a short and direct response. 1.09. What is the ratio of the Aid flow from UN agencies (US$) in Azerbaijan in 2000 to that in 2004?
Your response must be concise. 0.85. What is the ratio of the Aid flow from UN agencies (US$) of Ecuador in 2000 to that in 2004?
Your answer should be compact. 0.44. What is the ratio of the Aid flow from UN agencies (US$) of Honduras in 2000 to that in 2004?
Ensure brevity in your answer.  2.63. What is the ratio of the Aid flow from UN agencies (US$) in India in 2000 to that in 2004?
Provide a succinct answer. 1.04. What is the ratio of the Aid flow from UN agencies (US$) of Azerbaijan in 2000 to that in 2005?
Your response must be concise. 0.71. What is the ratio of the Aid flow from UN agencies (US$) in Ecuador in 2000 to that in 2005?
Provide a short and direct response. 0.3. What is the ratio of the Aid flow from UN agencies (US$) of Honduras in 2000 to that in 2005?
Your answer should be very brief. 2.45. What is the ratio of the Aid flow from UN agencies (US$) in India in 2000 to that in 2005?
Provide a succinct answer. 1.37. What is the ratio of the Aid flow from UN agencies (US$) of Azerbaijan in 2001 to that in 2002?
Provide a succinct answer. 1.02. What is the ratio of the Aid flow from UN agencies (US$) of Ecuador in 2001 to that in 2002?
Provide a short and direct response. 1.2. What is the ratio of the Aid flow from UN agencies (US$) in Honduras in 2001 to that in 2002?
Your answer should be compact. 0.06. What is the ratio of the Aid flow from UN agencies (US$) of India in 2001 to that in 2002?
Give a very brief answer. 0.83. What is the ratio of the Aid flow from UN agencies (US$) of Azerbaijan in 2001 to that in 2003?
Your answer should be very brief. 0.9. What is the ratio of the Aid flow from UN agencies (US$) of Ecuador in 2001 to that in 2003?
Your response must be concise. 9. What is the ratio of the Aid flow from UN agencies (US$) in Honduras in 2001 to that in 2003?
Make the answer very short. 0.07. What is the ratio of the Aid flow from UN agencies (US$) of India in 2001 to that in 2003?
Provide a short and direct response. 0.91. What is the ratio of the Aid flow from UN agencies (US$) in Azerbaijan in 2001 to that in 2004?
Provide a succinct answer. 0.91. What is the ratio of the Aid flow from UN agencies (US$) of Ecuador in 2001 to that in 2004?
Offer a terse response. 0.2. What is the ratio of the Aid flow from UN agencies (US$) of Honduras in 2001 to that in 2004?
Make the answer very short. 0.06. What is the ratio of the Aid flow from UN agencies (US$) in India in 2001 to that in 2004?
Your answer should be very brief. 0.87. What is the ratio of the Aid flow from UN agencies (US$) in Azerbaijan in 2001 to that in 2005?
Provide a short and direct response. 0.76. What is the ratio of the Aid flow from UN agencies (US$) of Ecuador in 2001 to that in 2005?
Ensure brevity in your answer.  0.13. What is the ratio of the Aid flow from UN agencies (US$) of Honduras in 2001 to that in 2005?
Provide a short and direct response. 0.05. What is the ratio of the Aid flow from UN agencies (US$) in India in 2001 to that in 2005?
Your response must be concise. 1.15. What is the ratio of the Aid flow from UN agencies (US$) in Azerbaijan in 2002 to that in 2003?
Provide a short and direct response. 0.89. What is the ratio of the Aid flow from UN agencies (US$) of Ecuador in 2002 to that in 2003?
Make the answer very short. 7.5. What is the ratio of the Aid flow from UN agencies (US$) of Honduras in 2002 to that in 2003?
Provide a succinct answer. 1.26. What is the ratio of the Aid flow from UN agencies (US$) in India in 2002 to that in 2003?
Offer a very short reply. 1.09. What is the ratio of the Aid flow from UN agencies (US$) in Azerbaijan in 2002 to that in 2004?
Keep it short and to the point. 0.89. What is the ratio of the Aid flow from UN agencies (US$) in Honduras in 2002 to that in 2004?
Provide a succinct answer. 1.02. What is the ratio of the Aid flow from UN agencies (US$) in India in 2002 to that in 2004?
Keep it short and to the point. 1.04. What is the ratio of the Aid flow from UN agencies (US$) of Azerbaijan in 2002 to that in 2005?
Offer a terse response. 0.75. What is the ratio of the Aid flow from UN agencies (US$) of Ecuador in 2002 to that in 2005?
Your response must be concise. 0.11. What is the ratio of the Aid flow from UN agencies (US$) in Honduras in 2002 to that in 2005?
Make the answer very short. 0.95. What is the ratio of the Aid flow from UN agencies (US$) of India in 2002 to that in 2005?
Give a very brief answer. 1.38. What is the ratio of the Aid flow from UN agencies (US$) in Azerbaijan in 2003 to that in 2004?
Offer a terse response. 1.01. What is the ratio of the Aid flow from UN agencies (US$) in Ecuador in 2003 to that in 2004?
Your answer should be compact. 0.02. What is the ratio of the Aid flow from UN agencies (US$) in Honduras in 2003 to that in 2004?
Your answer should be compact. 0.81. What is the ratio of the Aid flow from UN agencies (US$) of India in 2003 to that in 2004?
Provide a succinct answer. 0.96. What is the ratio of the Aid flow from UN agencies (US$) in Azerbaijan in 2003 to that in 2005?
Offer a terse response. 0.84. What is the ratio of the Aid flow from UN agencies (US$) of Ecuador in 2003 to that in 2005?
Your answer should be very brief. 0.01. What is the ratio of the Aid flow from UN agencies (US$) of Honduras in 2003 to that in 2005?
Provide a short and direct response. 0.75. What is the ratio of the Aid flow from UN agencies (US$) of India in 2003 to that in 2005?
Your answer should be compact. 1.27. What is the ratio of the Aid flow from UN agencies (US$) in Azerbaijan in 2004 to that in 2005?
Your answer should be compact. 0.84. What is the ratio of the Aid flow from UN agencies (US$) of Ecuador in 2004 to that in 2005?
Give a very brief answer. 0.67. What is the ratio of the Aid flow from UN agencies (US$) in India in 2004 to that in 2005?
Your answer should be compact. 1.32. What is the difference between the highest and the second highest Aid flow from UN agencies (US$) of Azerbaijan?
Your answer should be very brief. 2.00e+05. What is the difference between the highest and the second highest Aid flow from UN agencies (US$) of Ecuador?
Ensure brevity in your answer.  2.50e+05. What is the difference between the highest and the second highest Aid flow from UN agencies (US$) in Honduras?
Make the answer very short. 1.13e+06. What is the difference between the highest and the lowest Aid flow from UN agencies (US$) in Azerbaijan?
Provide a short and direct response. 1.57e+06. What is the difference between the highest and the lowest Aid flow from UN agencies (US$) in Ecuador?
Give a very brief answer. 2.10e+06. What is the difference between the highest and the lowest Aid flow from UN agencies (US$) of Honduras?
Your response must be concise. 3.82e+06. What is the difference between the highest and the lowest Aid flow from UN agencies (US$) in India?
Your response must be concise. 1.13e+07. 